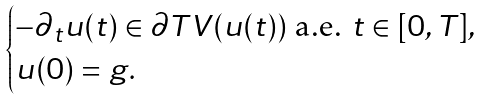<formula> <loc_0><loc_0><loc_500><loc_500>\begin{cases} - \partial _ { t } u ( t ) \in \partial T V ( u ( t ) ) \text { a.e. } t \in [ 0 , T ] , \\ u ( 0 ) = g . \end{cases}</formula> 